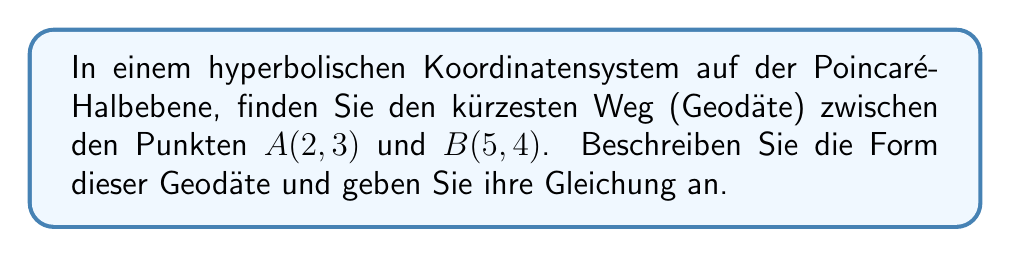Solve this math problem. 1. In der Poincaré-Halbebene sind Geodäten entweder vertikale Geraden oder Halbkreise, die senkrecht zur x-Achse stehen.

2. Da die Punkte $A$ und $B$ nicht auf einer vertikalen Linie liegen, suchen wir einen Halbkreis.

3. Die allgemeine Gleichung eines Kreises lautet:
   $$(x-h)^2 + (y-k)^2 = r^2$$
   wobei $(h,k)$ der Mittelpunkt und $r$ der Radius ist.

4. Für einen Halbkreis, der senkrecht zur x-Achse steht, gilt $k=0$. Also vereinfacht sich unsere Gleichung zu:
   $$(x-h)^2 + y^2 = r^2$$

5. Wir haben zwei Punkte $(2,3)$ und $(5,4)$, die auf diesem Halbkreis liegen müssen. Setzen wir diese in die Gleichung ein:
   $$(2-h)^2 + 3^2 = r^2$$
   $$(5-h)^2 + 4^2 = r^2$$

6. Subtrahieren wir die erste Gleichung von der zweiten:
   $(5-h)^2 - (2-h)^2 = 4^2 - 3^2$
   $25 - 10h + h^2 - (4 - 4h + h^2) = 16 - 9$
   $21 - 6h = 7$
   $-6h = -14$
   $h = \frac{7}{3}$

7. Jetzt können wir $h$ in eine der ursprünglichen Gleichungen einsetzen, um $r$ zu finden:
   $(2-\frac{7}{3})^2 + 3^2 = r^2$
   $(\frac{-1}{3})^2 + 9 = r^2$
   $\frac{1}{9} + 9 = r^2$
   $r^2 = \frac{82}{9}$
   $r = \frac{\sqrt{82}}{3}$

8. Die Gleichung des Halbkreises lautet also:
   $$(x-\frac{7}{3})^2 + y^2 = (\frac{\sqrt{82}}{3})^2$$
Answer: $(x-\frac{7}{3})^2 + y^2 = (\frac{\sqrt{82}}{3})^2$ 